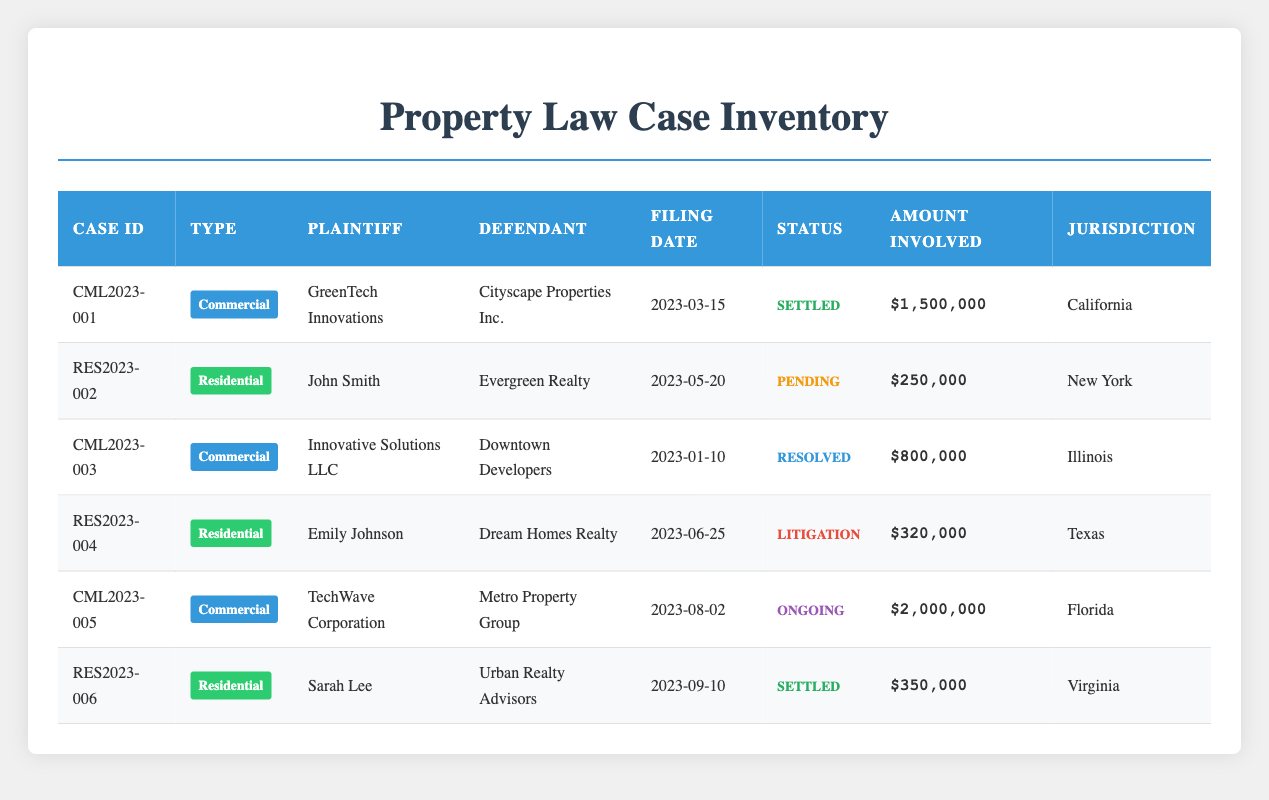What is the total amount involved in commercial property lawsuits? To find the total amount involved in commercial property lawsuits, I will first list all the amounts for the commercial cases: $1,500,000 (CML2023-001), $800,000 (CML2023-003), and $2,000,000 (CML2023-005). Next, I sum these amounts: 1,500,000 + 800,000 + 2,000,000 = 4,300,000.
Answer: 4,300,000 How many residential lawsuits are currently pending? In the table, I see that there is one residential lawsuit listed as pending: John Smith vs. Evergreen Realty (RES2023-002). As it is the only case with the status "Pending," the answer is one.
Answer: 1 Which jurisdiction has the highest amount involved in lawsuits? I will compare the amount involved in each lawsuit in the table: California has $1,500,000 (CML2023-001), New York has $250,000 (RES2023-002), Illinois has $800,000 (CML2023-003), Texas has $320,000 (RES2023-004), Florida has $2,000,000 (CML2023-005), and Virginia has $350,000 (RES2023-006). The highest amount is $2,000,000 from Florida.
Answer: Florida Is there a residential case that has been resolved? Examining the table, I see there are two residential cases, one pending and one in litigation. There is no entry that indicates a resolved status for any residential case. Therefore, there is no residential lawsuit that has been resolved.
Answer: No What percentage of the total lawsuits are commercial cases? There are six total cases: three commercial (CML2023-001, CML2023-003, CML2023-005) and three residential (RES2023-002, RES2023-004, RES2023-006). This means 3 out of 6 cases are commercial. To find the percentage, I calculate (commercial cases/total cases) * 100 = (3/6) * 100 = 50%.
Answer: 50% What is the status of the most recent lawsuit filed? Looking at the Filing Dates, the most recent lawsuit is Sarah Lee vs. Urban Realty Advisors (RES2023-006) filed on September 10, 2023. The status of this case is "Settled."
Answer: Settled Are there more commercial lawsuits than residential lawsuits? In total, there are three commercial lawsuits and three residential lawsuits. Since the counts are equal, the answer is no; there are not more commercial lawsuits.
Answer: No What is the earliest filing date for a commercial property lawsuit? To find this, I compare the filing dates of the commercial cases: March 15, 2023 (CML2023-001), January 10, 2023 (CML2023-003), and August 2, 2023 (CML2023-005). The earliest date is January 10, 2023, for Innovative Solutions LLC vs. Downtown Developers.
Answer: January 10, 2023 